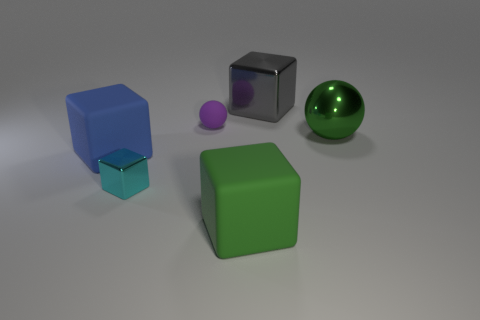Subtract all large cubes. How many cubes are left? 1 Add 2 tiny brown rubber objects. How many objects exist? 8 Subtract 3 blocks. How many blocks are left? 1 Subtract all cyan cubes. How many cubes are left? 3 Subtract all green cubes. How many purple balls are left? 1 Add 5 blue matte blocks. How many blue matte blocks exist? 6 Subtract 0 cyan cylinders. How many objects are left? 6 Subtract all balls. How many objects are left? 4 Subtract all cyan cubes. Subtract all green cylinders. How many cubes are left? 3 Subtract all large blue rubber blocks. Subtract all big gray blocks. How many objects are left? 4 